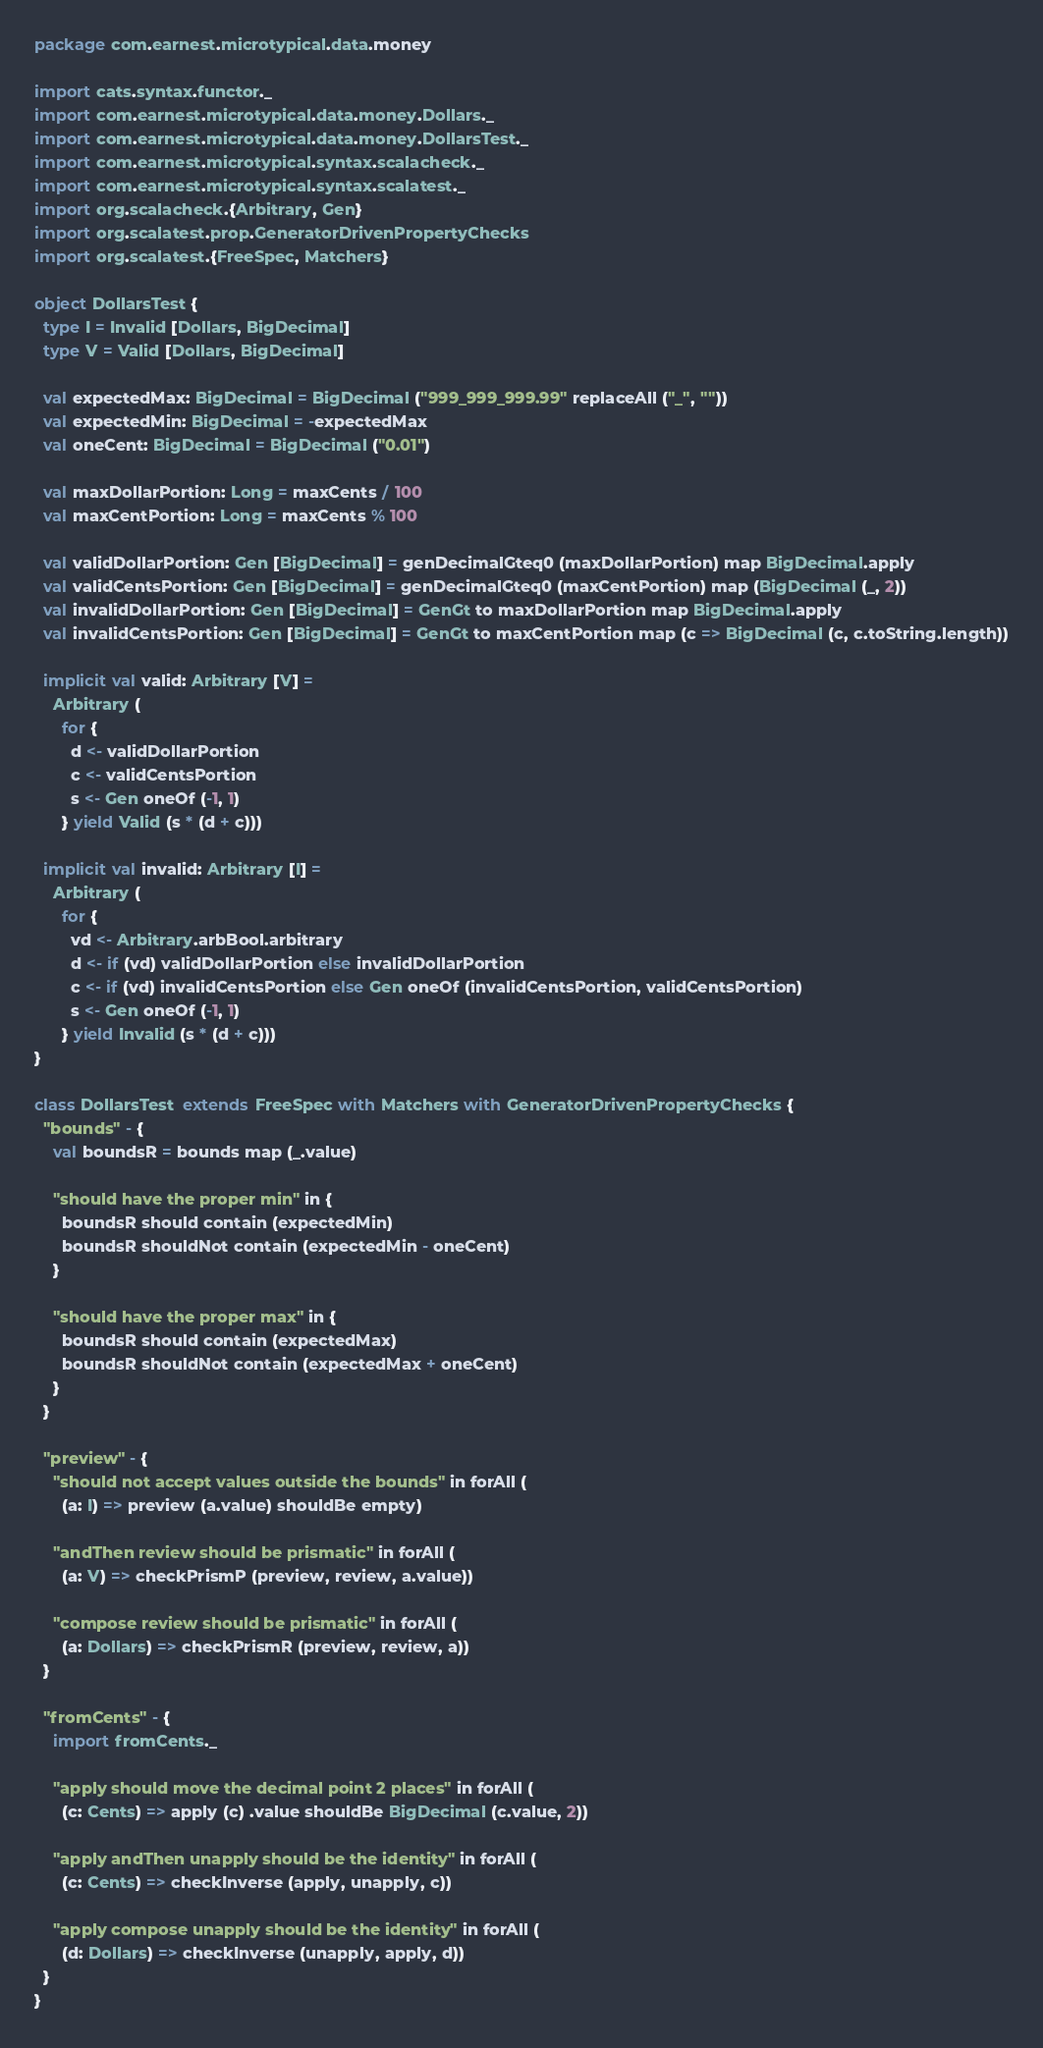<code> <loc_0><loc_0><loc_500><loc_500><_Scala_>package com.earnest.microtypical.data.money

import cats.syntax.functor._
import com.earnest.microtypical.data.money.Dollars._
import com.earnest.microtypical.data.money.DollarsTest._
import com.earnest.microtypical.syntax.scalacheck._
import com.earnest.microtypical.syntax.scalatest._
import org.scalacheck.{Arbitrary, Gen}
import org.scalatest.prop.GeneratorDrivenPropertyChecks
import org.scalatest.{FreeSpec, Matchers}

object DollarsTest {
  type I = Invalid [Dollars, BigDecimal]
  type V = Valid [Dollars, BigDecimal]

  val expectedMax: BigDecimal = BigDecimal ("999_999_999.99" replaceAll ("_", ""))
  val expectedMin: BigDecimal = -expectedMax
  val oneCent: BigDecimal = BigDecimal ("0.01")

  val maxDollarPortion: Long = maxCents / 100
  val maxCentPortion: Long = maxCents % 100

  val validDollarPortion: Gen [BigDecimal] = genDecimalGteq0 (maxDollarPortion) map BigDecimal.apply
  val validCentsPortion: Gen [BigDecimal] = genDecimalGteq0 (maxCentPortion) map (BigDecimal (_, 2))
  val invalidDollarPortion: Gen [BigDecimal] = GenGt to maxDollarPortion map BigDecimal.apply
  val invalidCentsPortion: Gen [BigDecimal] = GenGt to maxCentPortion map (c => BigDecimal (c, c.toString.length))

  implicit val valid: Arbitrary [V] =
    Arbitrary (
      for {
        d <- validDollarPortion
        c <- validCentsPortion
        s <- Gen oneOf (-1, 1)
      } yield Valid (s * (d + c)))

  implicit val invalid: Arbitrary [I] =
    Arbitrary (
      for {
        vd <- Arbitrary.arbBool.arbitrary
        d <- if (vd) validDollarPortion else invalidDollarPortion
        c <- if (vd) invalidCentsPortion else Gen oneOf (invalidCentsPortion, validCentsPortion)
        s <- Gen oneOf (-1, 1)
      } yield Invalid (s * (d + c)))
}

class DollarsTest  extends FreeSpec with Matchers with GeneratorDrivenPropertyChecks {
  "bounds" - {
    val boundsR = bounds map (_.value)

    "should have the proper min" in {
      boundsR should contain (expectedMin)
      boundsR shouldNot contain (expectedMin - oneCent)
    }

    "should have the proper max" in {
      boundsR should contain (expectedMax)
      boundsR shouldNot contain (expectedMax + oneCent)
    }
  }

  "preview" - {
    "should not accept values outside the bounds" in forAll (
      (a: I) => preview (a.value) shouldBe empty)

    "andThen review should be prismatic" in forAll (
      (a: V) => checkPrismP (preview, review, a.value))

    "compose review should be prismatic" in forAll (
      (a: Dollars) => checkPrismR (preview, review, a))
  }

  "fromCents" - {
    import fromCents._

    "apply should move the decimal point 2 places" in forAll (
      (c: Cents) => apply (c) .value shouldBe BigDecimal (c.value, 2))

    "apply andThen unapply should be the identity" in forAll (
      (c: Cents) => checkInverse (apply, unapply, c))

    "apply compose unapply should be the identity" in forAll (
      (d: Dollars) => checkInverse (unapply, apply, d))
  }
}
</code> 